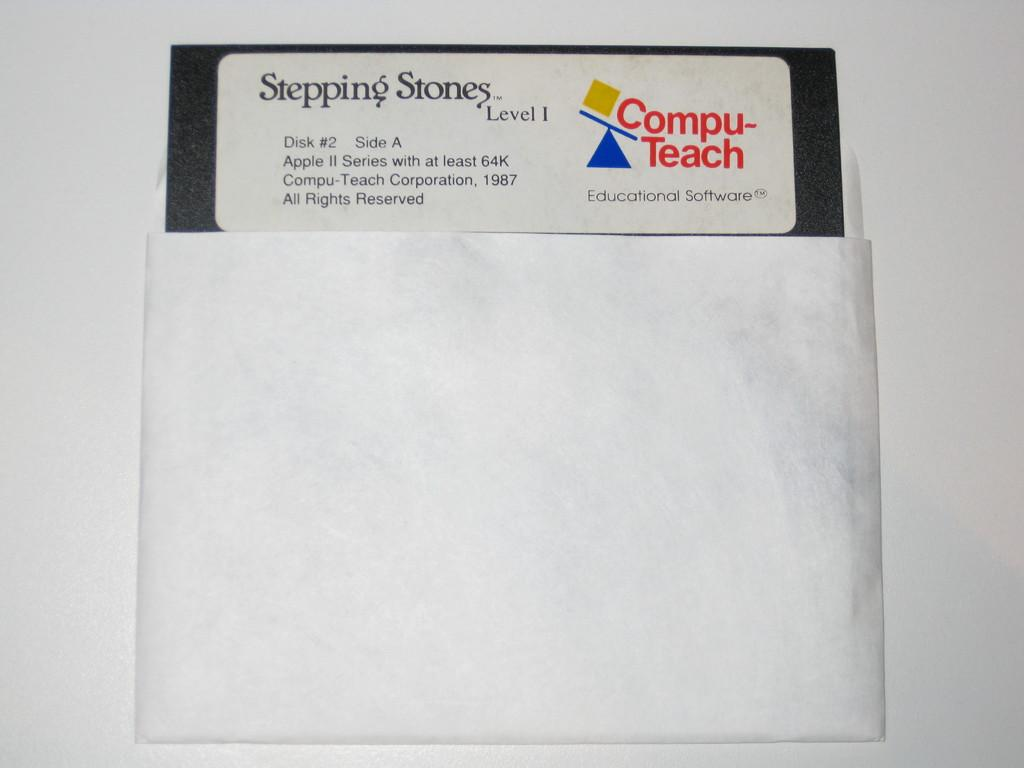<image>
Relay a brief, clear account of the picture shown. a stepping stones floppy disk is in its sleeve 